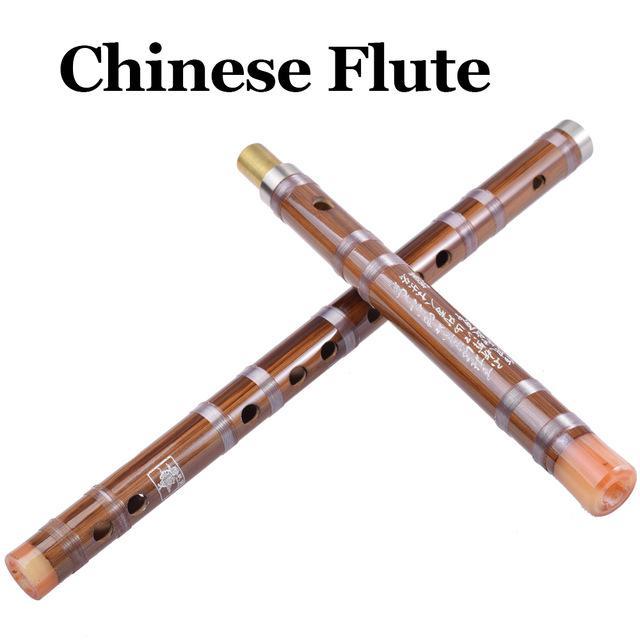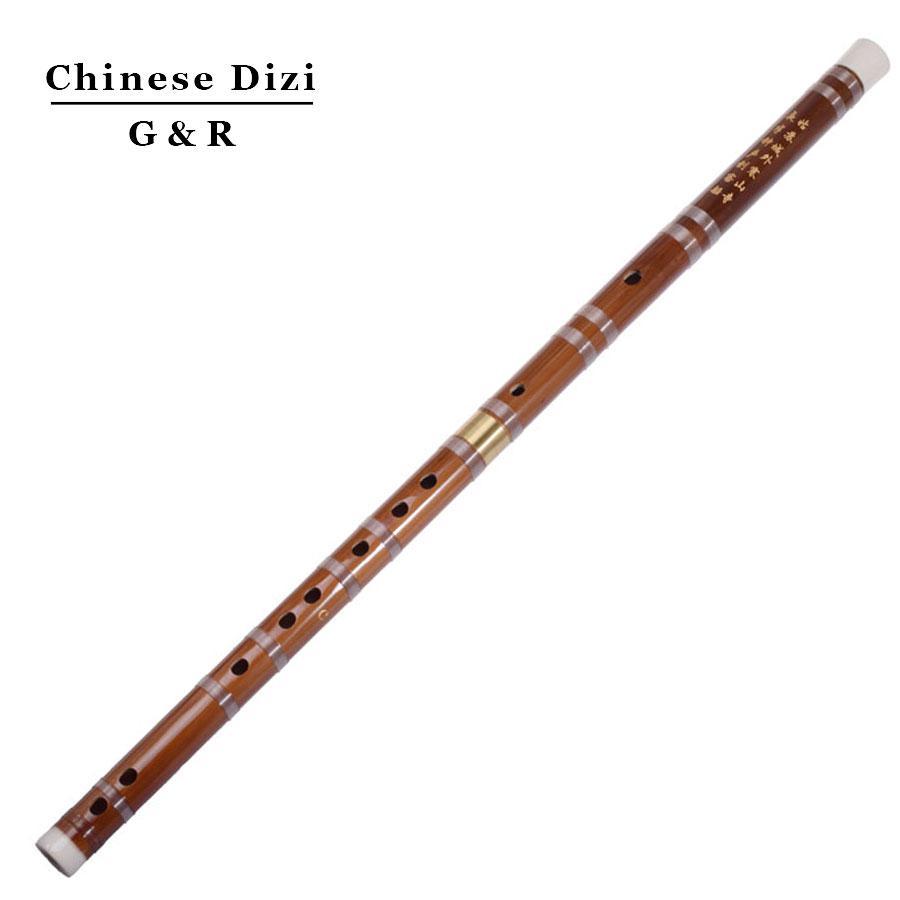The first image is the image on the left, the second image is the image on the right. For the images shown, is this caption "There are exactly two assembled flutes." true? Answer yes or no. No. 